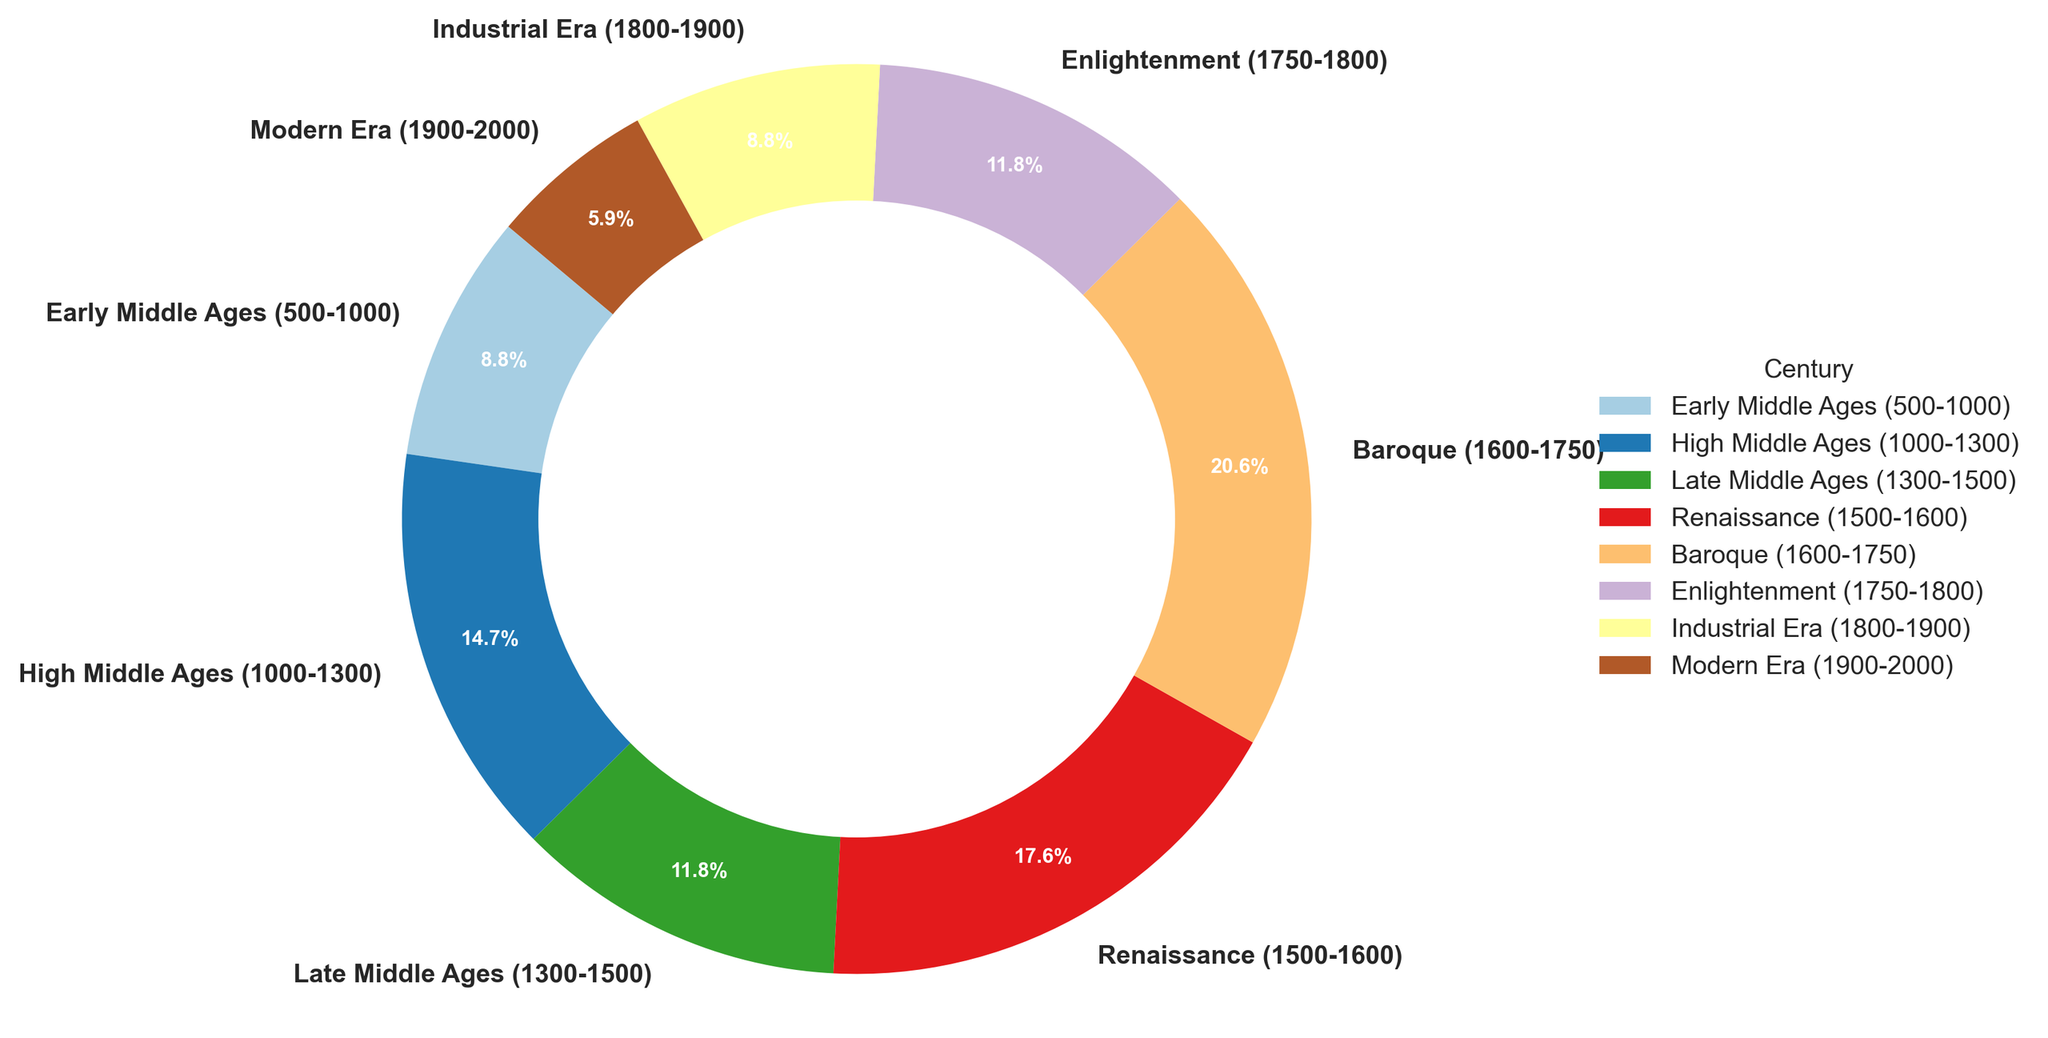Which century has the smallest percentage of historical landmarks? To find which century has the smallest percentage of historical landmarks, look for the slice with the smallest size on the pie chart. The Modern Era (1900-2000) has the smallest slice.
Answer: Modern Era (1900-2000) What percentage of landmarks originate from the Renaissance? Look at the pie chart slice labeled "Renaissance (1500-1600)" and note the percentage indicated by the label next to it. The Renaissance has 15.7%.
Answer: 15.7% How many historical landmarks are from the High Middle Ages compared to the Early Middle Ages? Count the number of landmarks from the High Middle Ages (25) and the Early Middle Ages (15). Then, subtract the two: 25 - 15 = 10.
Answer: 10 more landmarks What is the combined percentage of landmarks from the Baroque and Enlightenment periods? Find the percentages for Baroque (18.3%) and Enlightenment (10.4%) on the pie chart and add them up: 18.3% + 10.4% = 28.7%.
Answer: 28.7% Is the number of landmarks from the Industrial Era greater than those from the Late Middle Ages? Compare the number of landmarks for the Industrial Era (15) against the Late Middle Ages (20). Since 15 is less than 20, the number from the Industrial Era is not greater.
Answer: No How does the number of landmarks from the Renaissance compare to those from the Baroque period? Compare the number of landmarks from the Renaissance (30) to those from the Baroque period (35). Since 35 is greater than 30, the Baroque period has more landmarks.
Answer: Baroque period has more What is the ratio of landmarks between the Early Middle Ages and the Modern Era? Calculate the ratio by dividing the number of landmarks from the Early Middle Ages (15) by those of the Modern Era (10): 15/10 = 1.5.
Answer: 1.5:1 What percentage of historical landmarks come from the periods before 1800? Add up the percentages for all periods before 1800: Early Middle Ages (7.9%), High Middle Ages (13.2%), Late Middle Ages (10.5%), Renaissance (15.7%), Baroque (18.3%), and Enlightenment (10.4%). Summing these gives: 7.9% + 13.2% + 10.5% + 15.7% + 18.3% + 10.4% = 76%.
Answer: 76% Compare the total landmarks originating from the Middle Ages (500-1500) to those from the Renaissance and Baroque periods combined (1500-1750). Sum the number of landmarks from the Early (15), High (25), and Late Middle Ages (20) for a total of 60. Then, sum the landmarks from the Renaissance (30) and Baroque periods (35) for a total of 65. Compare 60 and 65 to see that 65 is greater.
Answer: Renaissance and Baroque periods combined have more Is the Enlightenment period represented with a higher percentage than the Industrial Era? Compare the percentages for the Enlightenment (10.4%) and the Industrial Era (7.9%) on the pie chart. Since 10.4% is greater than 7.9%, the Enlightenment period is represented with a higher percentage.
Answer: Yes 